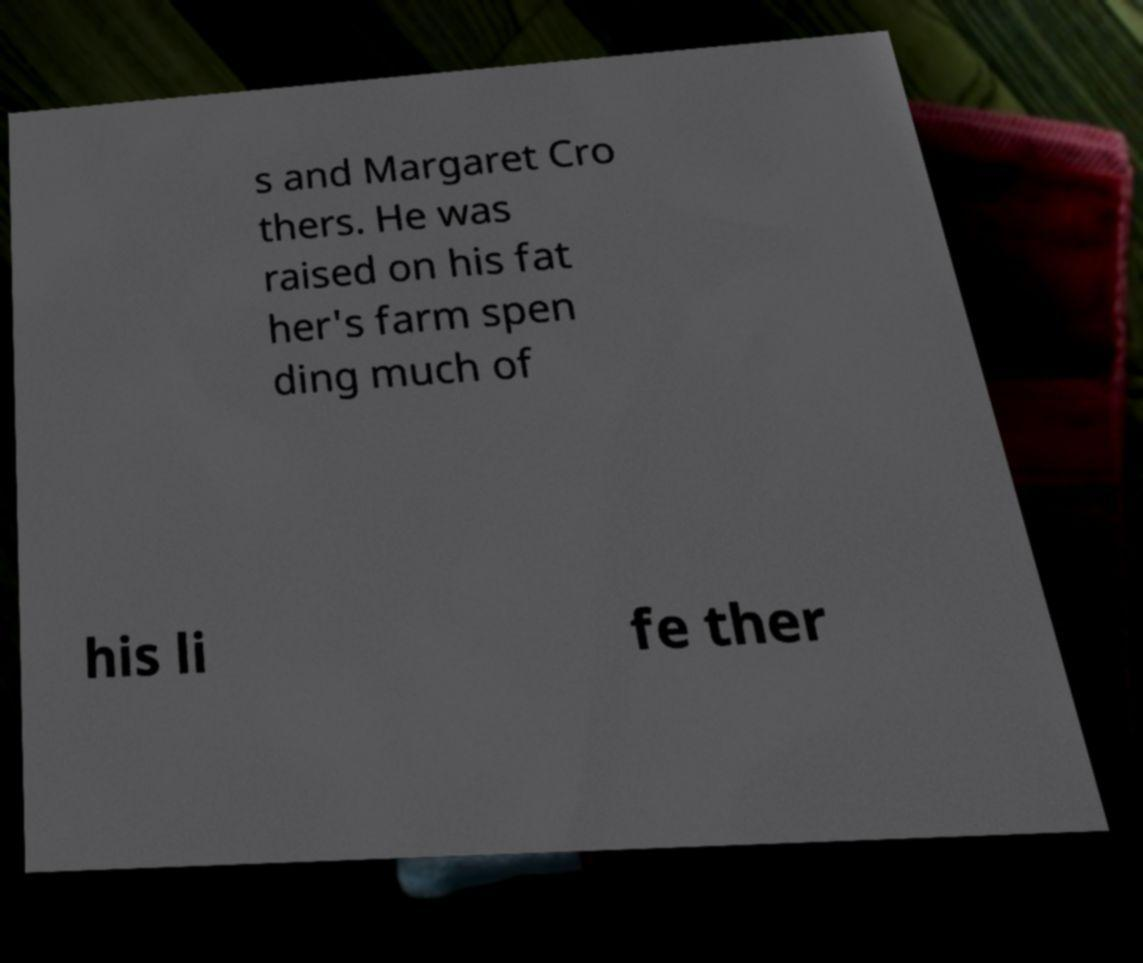What messages or text are displayed in this image? I need them in a readable, typed format. s and Margaret Cro thers. He was raised on his fat her's farm spen ding much of his li fe ther 